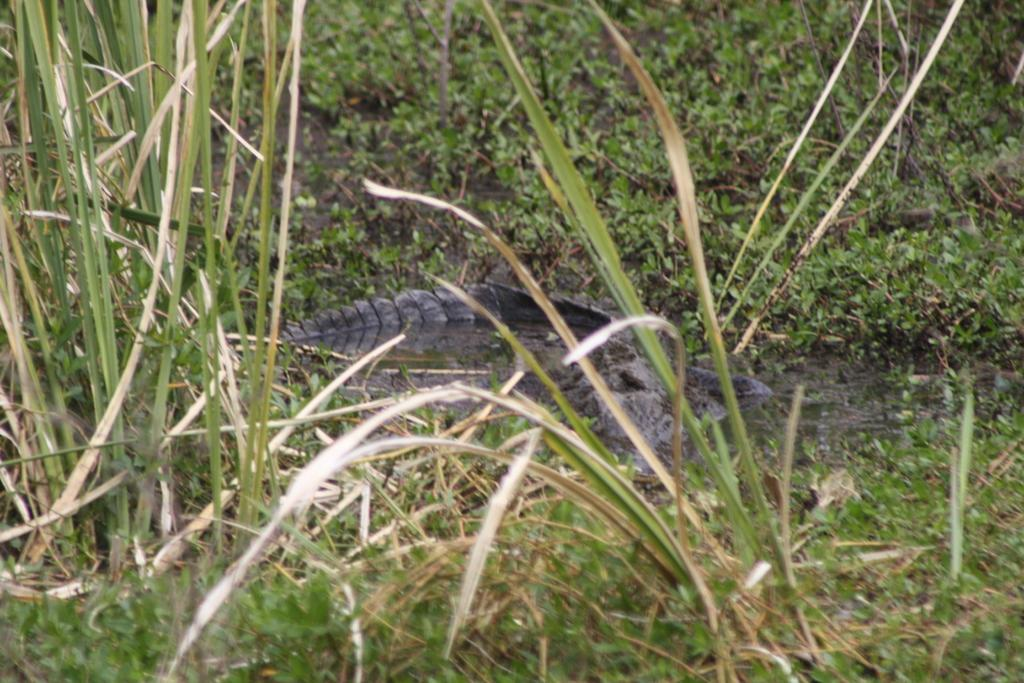What is the main subject in the center of the image? There is a crocodile in the center of the image. What is the crocodile's location in relation to the water? The crocodile is on the water. What can be seen in the background of the image? There are plants visible in the background of the image. What type of music is the frog playing in the image? There is no frog or music present in the image; it features a crocodile on the water with plants in the background. 